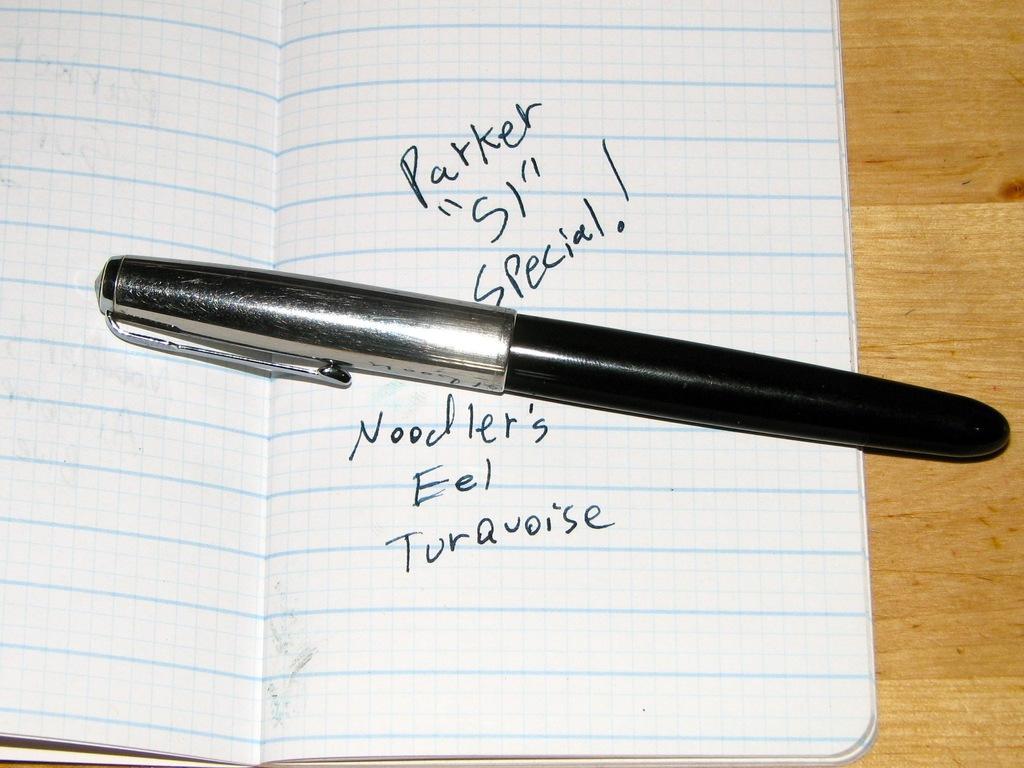Could you give a brief overview of what you see in this image? This image consists of a pen kept on a book. The book is kept on a table which is made up of wood. The pen is in black color. 